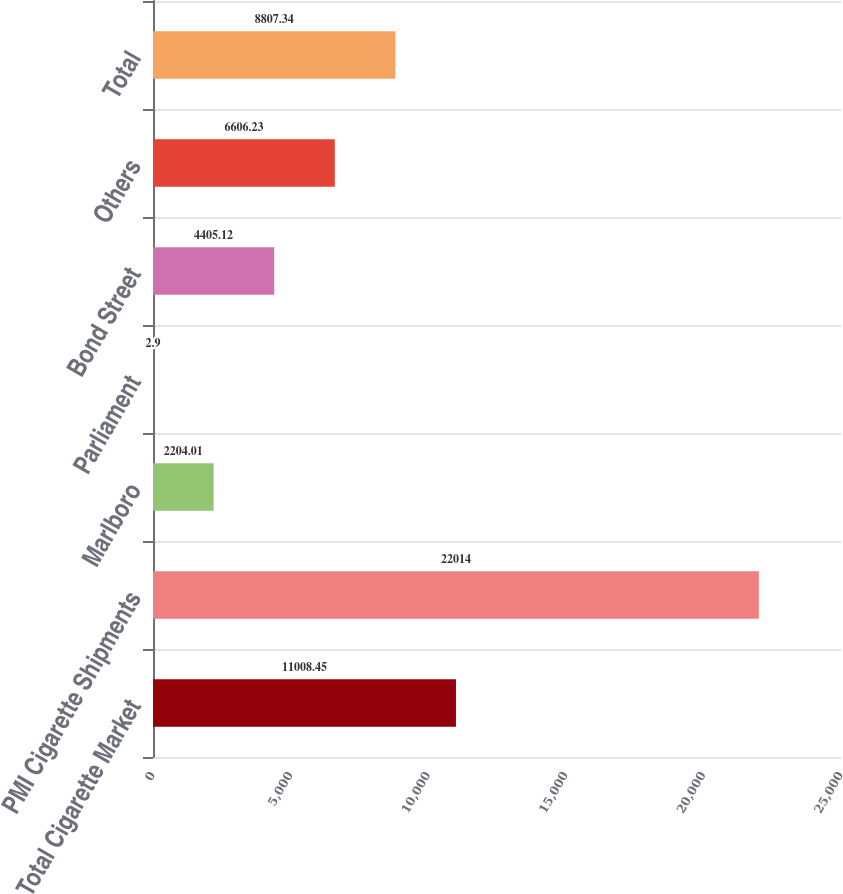<chart> <loc_0><loc_0><loc_500><loc_500><bar_chart><fcel>Total Cigarette Market<fcel>PMI Cigarette Shipments<fcel>Marlboro<fcel>Parliament<fcel>Bond Street<fcel>Others<fcel>Total<nl><fcel>11008.5<fcel>22014<fcel>2204.01<fcel>2.9<fcel>4405.12<fcel>6606.23<fcel>8807.34<nl></chart> 